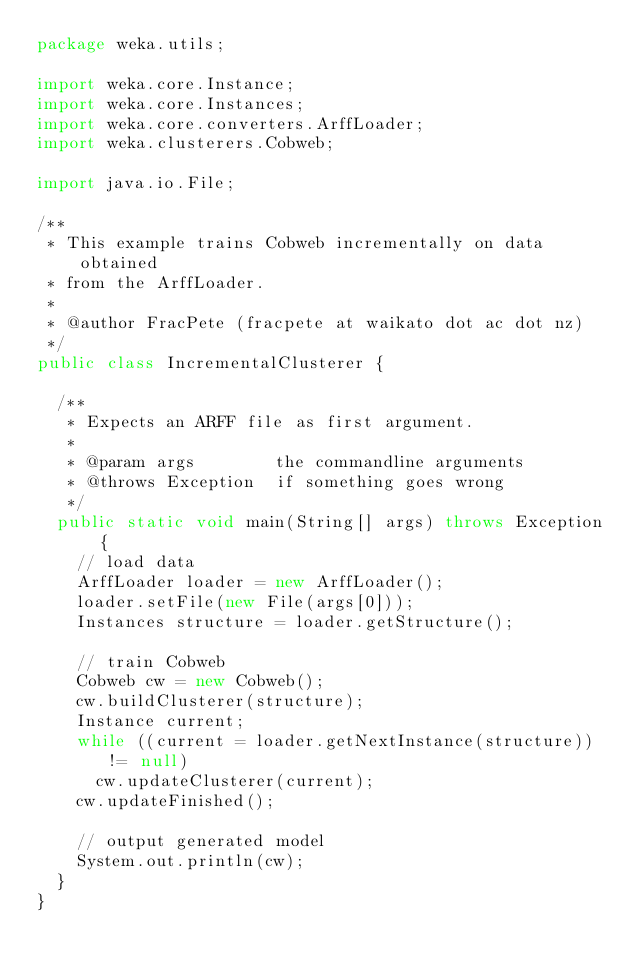Convert code to text. <code><loc_0><loc_0><loc_500><loc_500><_Java_>package weka.utils;

import weka.core.Instance;
import weka.core.Instances;
import weka.core.converters.ArffLoader;
import weka.clusterers.Cobweb;

import java.io.File;

/**
 * This example trains Cobweb incrementally on data obtained
 * from the ArffLoader.
 *
 * @author FracPete (fracpete at waikato dot ac dot nz)
 */
public class IncrementalClusterer {

  /**
   * Expects an ARFF file as first argument.
   *
   * @param args        the commandline arguments
   * @throws Exception  if something goes wrong
   */
  public static void main(String[] args) throws Exception {
    // load data
    ArffLoader loader = new ArffLoader();
    loader.setFile(new File(args[0]));
    Instances structure = loader.getStructure();

    // train Cobweb
    Cobweb cw = new Cobweb();
    cw.buildClusterer(structure);
    Instance current;
    while ((current = loader.getNextInstance(structure)) != null)
      cw.updateClusterer(current);
    cw.updateFinished();

    // output generated model
    System.out.println(cw);
  }
}</code> 